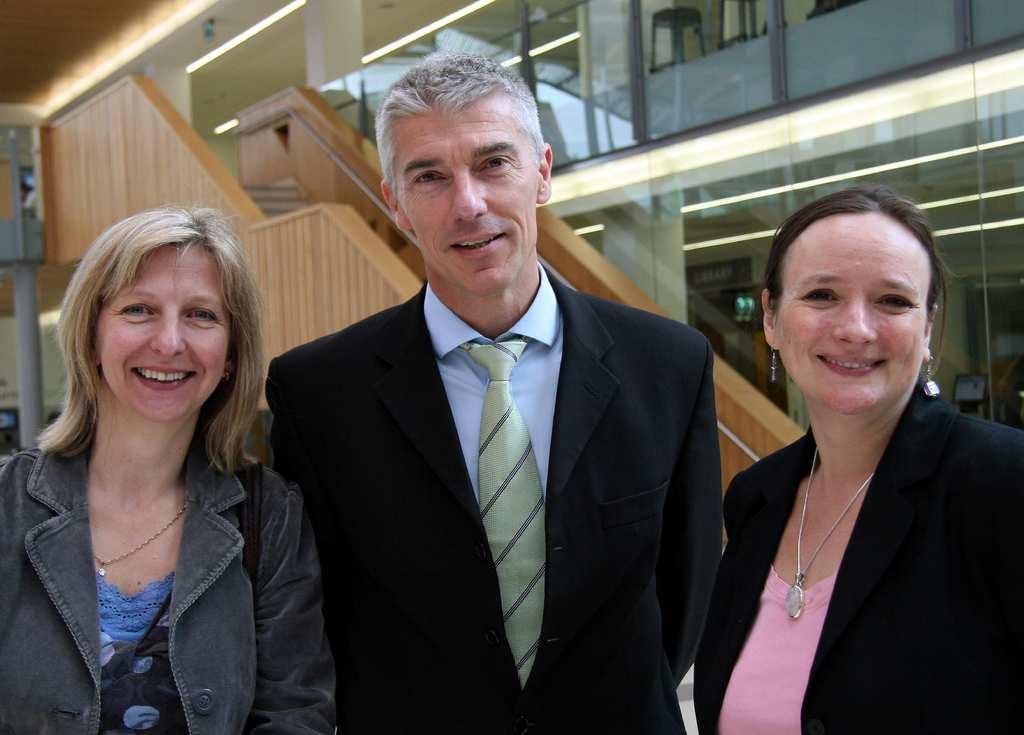How would you summarize this image in a sentence or two? In this image, I can see the man and woman standing and smiling. These are the glass doors. I think these are the stairs with a staircase holder. On the left side of the image, that looks like a pole. 